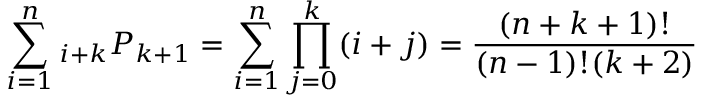Convert formula to latex. <formula><loc_0><loc_0><loc_500><loc_500>\sum _ { i = 1 } ^ { n _ { i + k } P _ { k + 1 } = \sum _ { i = 1 } ^ { n } \prod _ { j = 0 } ^ { k } ( i + j ) = { \frac { ( n + k + 1 ) ! } { ( n - 1 ) ! ( k + 2 ) } }</formula> 